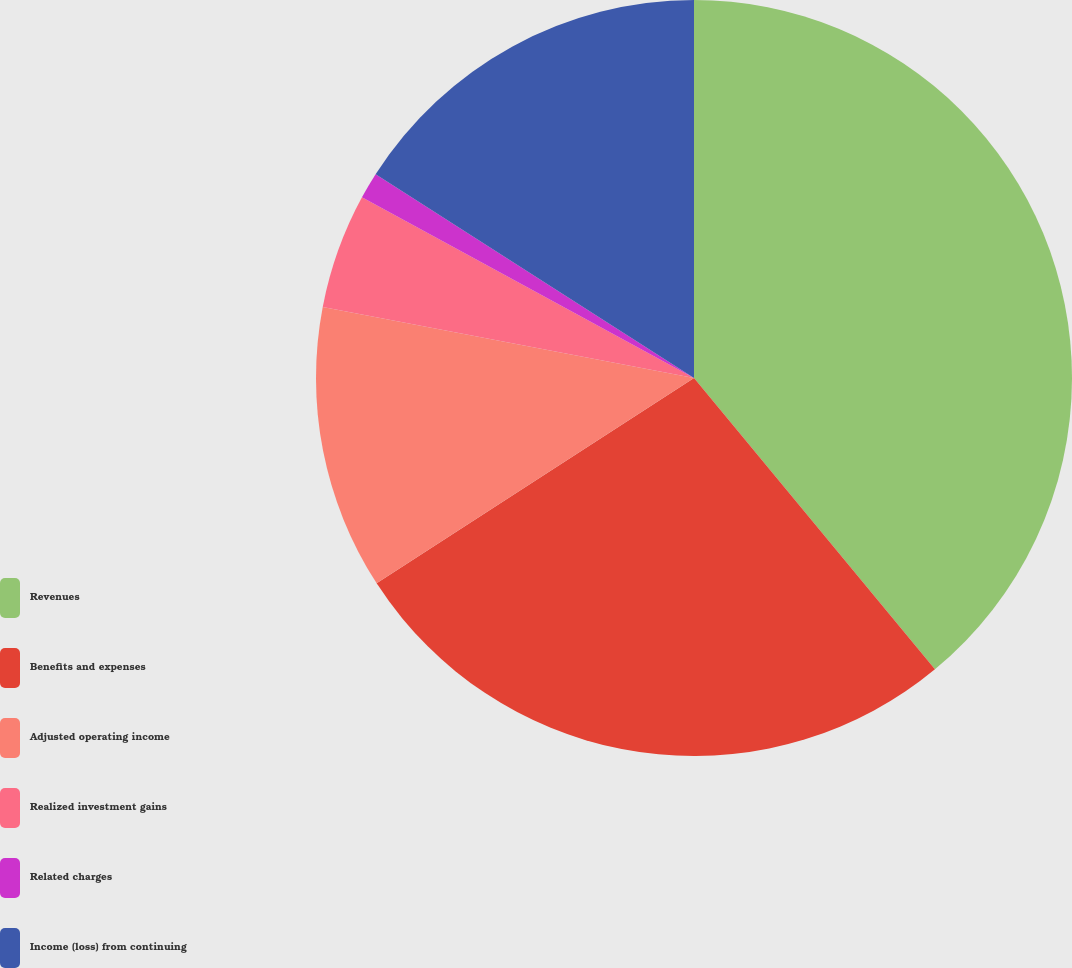<chart> <loc_0><loc_0><loc_500><loc_500><pie_chart><fcel>Revenues<fcel>Benefits and expenses<fcel>Adjusted operating income<fcel>Realized investment gains<fcel>Related charges<fcel>Income (loss) from continuing<nl><fcel>39.0%<fcel>26.86%<fcel>12.15%<fcel>4.92%<fcel>1.13%<fcel>15.94%<nl></chart> 